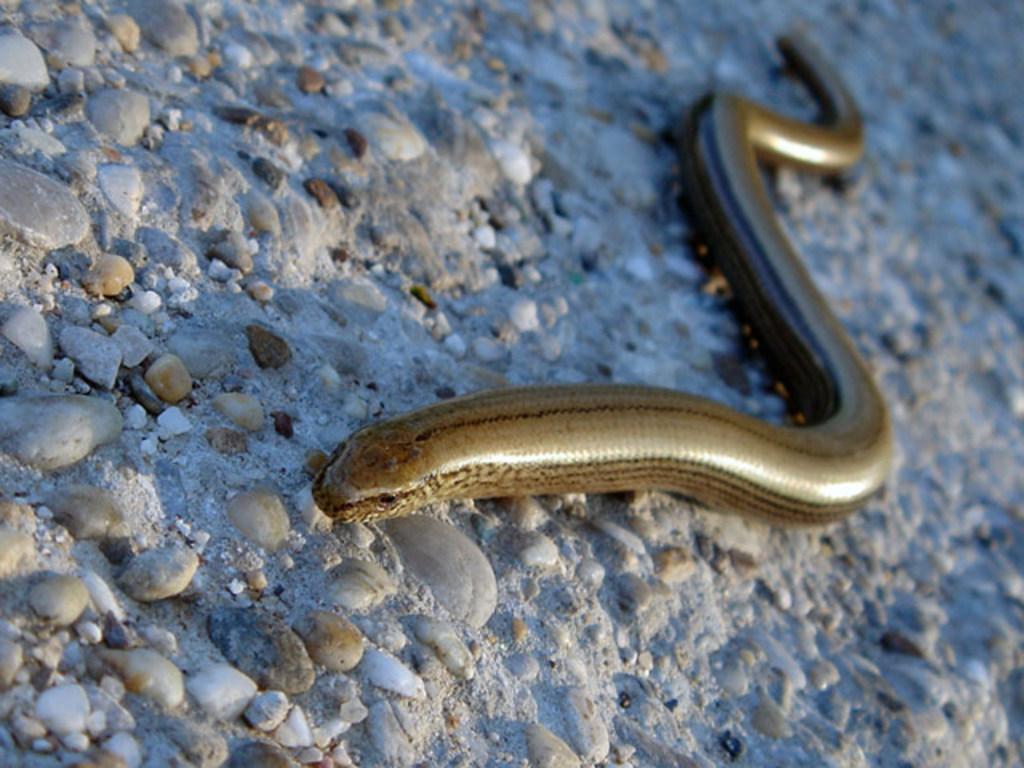In one or two sentences, can you explain what this image depicts? It is a snake which is moving on the stones. 